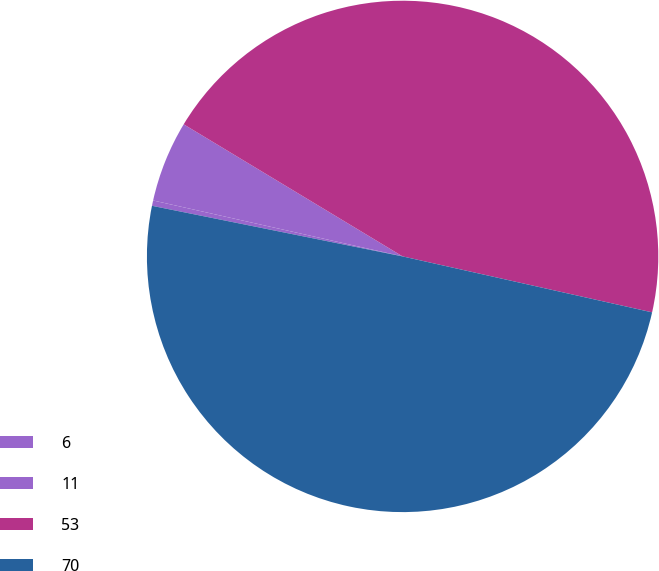Convert chart to OTSL. <chart><loc_0><loc_0><loc_500><loc_500><pie_chart><fcel>6<fcel>11<fcel>53<fcel>70<nl><fcel>0.34%<fcel>5.13%<fcel>44.87%<fcel>49.66%<nl></chart> 